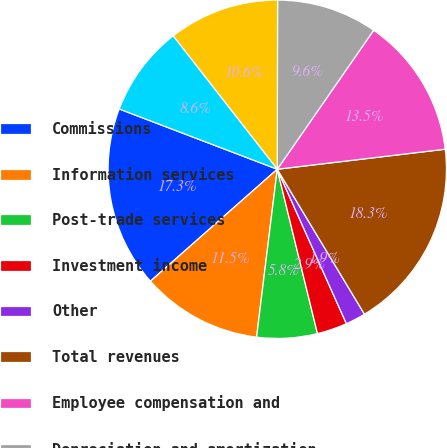<chart> <loc_0><loc_0><loc_500><loc_500><pie_chart><fcel>Commissions<fcel>Information services<fcel>Post-trade services<fcel>Investment income<fcel>Other<fcel>Total revenues<fcel>Employee compensation and<fcel>Depreciation and amortization<fcel>Technology and communications<fcel>Professional and consulting<nl><fcel>17.31%<fcel>11.54%<fcel>5.77%<fcel>2.88%<fcel>1.92%<fcel>18.27%<fcel>13.46%<fcel>9.62%<fcel>10.58%<fcel>8.65%<nl></chart> 